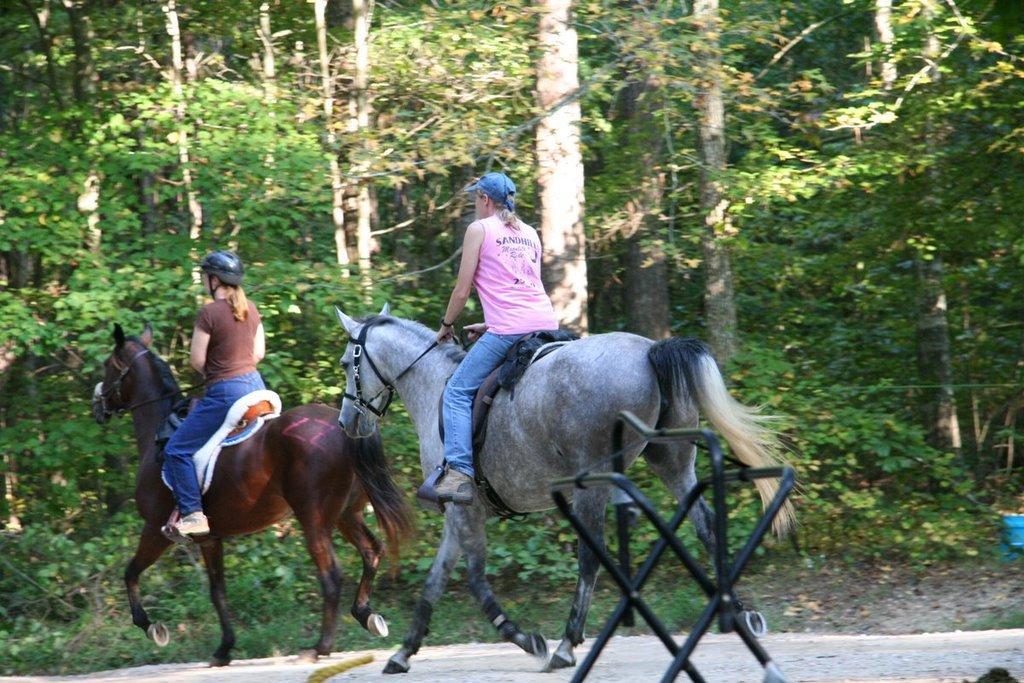In one or two sentences, can you explain what this image depicts? In this image in the middle, there is a horse on that there is a woman, she wears a t shirt, trouser, shoes and cap. On the left there is a horse on that there is a woman, she wears a t shirt, trouser, shoes and cap, she is riding a horse. In the background there are trees, plants and land. 